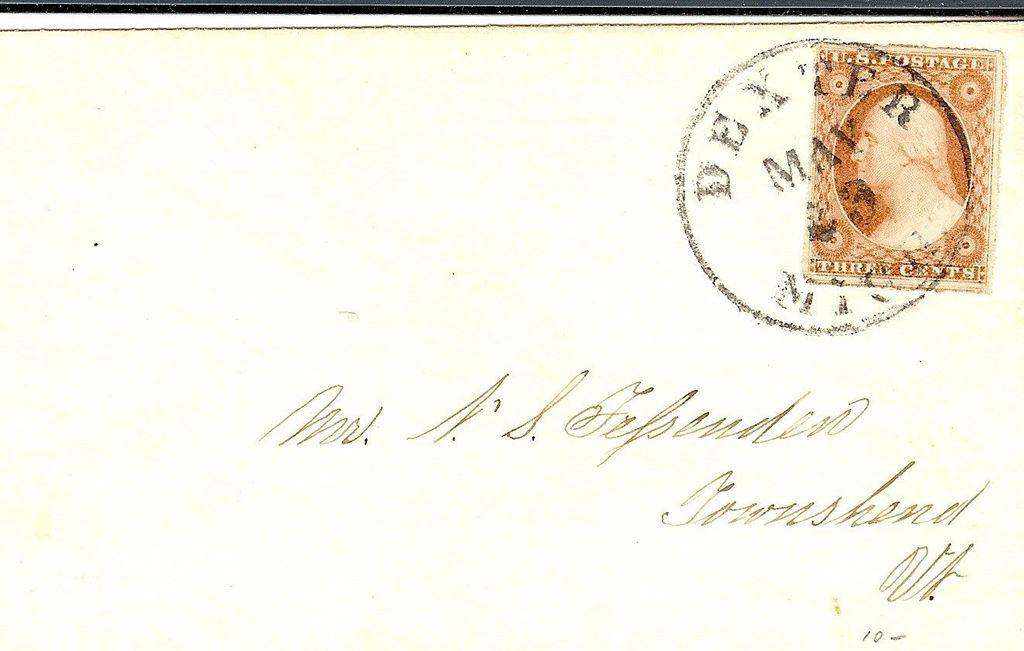<image>
Summarize the visual content of the image. the envelope was mailed from Dexter in May 